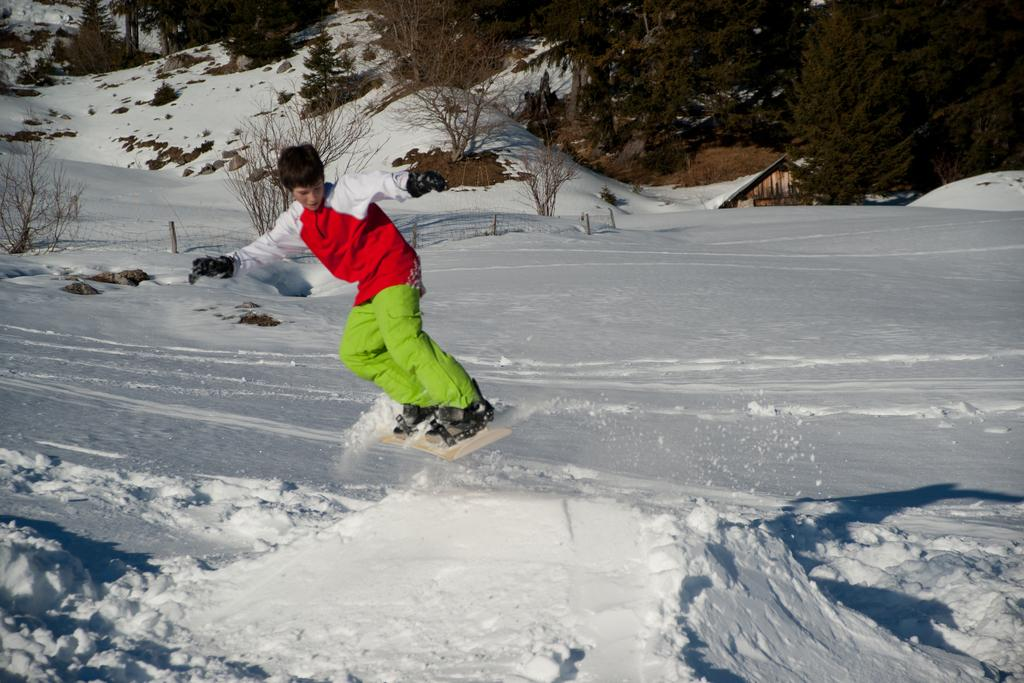Who is the main subject in the image? There is a boy in the image. What is the boy doing in the image? The boy is skating on the surface of the snow. What can be seen in the background of the image? There is a hut and trees in the background of the image. What type of rest is the judge taking in the image? There is no judge or rest present in the image; it features a boy skating on the snow with a hut and trees in the background. 